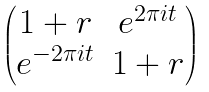<formula> <loc_0><loc_0><loc_500><loc_500>\begin{pmatrix} 1 + r & e ^ { 2 \pi i t } \\ e ^ { - 2 \pi i t } & 1 + r \end{pmatrix}</formula> 